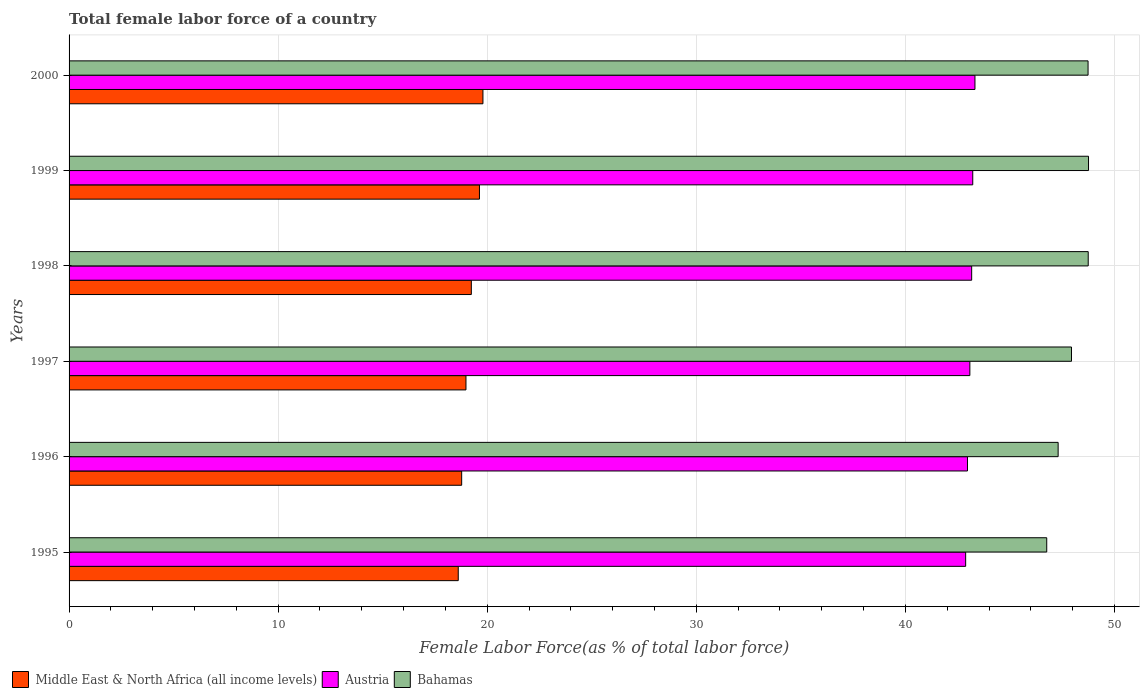How many different coloured bars are there?
Offer a very short reply. 3. Are the number of bars on each tick of the Y-axis equal?
Your answer should be very brief. Yes. In how many cases, is the number of bars for a given year not equal to the number of legend labels?
Provide a succinct answer. 0. What is the percentage of female labor force in Austria in 1999?
Offer a terse response. 43.22. Across all years, what is the maximum percentage of female labor force in Austria?
Your answer should be very brief. 43.33. Across all years, what is the minimum percentage of female labor force in Bahamas?
Your response must be concise. 46.76. What is the total percentage of female labor force in Bahamas in the graph?
Your answer should be compact. 288.25. What is the difference between the percentage of female labor force in Middle East & North Africa (all income levels) in 1995 and that in 1996?
Your answer should be compact. -0.16. What is the difference between the percentage of female labor force in Austria in 2000 and the percentage of female labor force in Bahamas in 1997?
Keep it short and to the point. -4.62. What is the average percentage of female labor force in Austria per year?
Give a very brief answer. 43.11. In the year 1995, what is the difference between the percentage of female labor force in Bahamas and percentage of female labor force in Middle East & North Africa (all income levels)?
Offer a very short reply. 28.15. In how many years, is the percentage of female labor force in Bahamas greater than 12 %?
Your answer should be compact. 6. What is the ratio of the percentage of female labor force in Middle East & North Africa (all income levels) in 1998 to that in 1999?
Your answer should be very brief. 0.98. What is the difference between the highest and the second highest percentage of female labor force in Bahamas?
Offer a very short reply. 0.01. What is the difference between the highest and the lowest percentage of female labor force in Austria?
Keep it short and to the point. 0.44. In how many years, is the percentage of female labor force in Bahamas greater than the average percentage of female labor force in Bahamas taken over all years?
Keep it short and to the point. 3. Is the sum of the percentage of female labor force in Austria in 1997 and 1998 greater than the maximum percentage of female labor force in Middle East & North Africa (all income levels) across all years?
Your answer should be very brief. Yes. What does the 1st bar from the top in 1999 represents?
Give a very brief answer. Bahamas. What does the 1st bar from the bottom in 1995 represents?
Your answer should be very brief. Middle East & North Africa (all income levels). Is it the case that in every year, the sum of the percentage of female labor force in Austria and percentage of female labor force in Middle East & North Africa (all income levels) is greater than the percentage of female labor force in Bahamas?
Keep it short and to the point. Yes. How many bars are there?
Give a very brief answer. 18. How many years are there in the graph?
Offer a terse response. 6. What is the difference between two consecutive major ticks on the X-axis?
Provide a short and direct response. 10. Does the graph contain any zero values?
Give a very brief answer. No. Does the graph contain grids?
Give a very brief answer. Yes. Where does the legend appear in the graph?
Make the answer very short. Bottom left. How many legend labels are there?
Your answer should be compact. 3. How are the legend labels stacked?
Offer a terse response. Horizontal. What is the title of the graph?
Your response must be concise. Total female labor force of a country. What is the label or title of the X-axis?
Offer a very short reply. Female Labor Force(as % of total labor force). What is the label or title of the Y-axis?
Keep it short and to the point. Years. What is the Female Labor Force(as % of total labor force) in Middle East & North Africa (all income levels) in 1995?
Ensure brevity in your answer.  18.61. What is the Female Labor Force(as % of total labor force) of Austria in 1995?
Ensure brevity in your answer.  42.88. What is the Female Labor Force(as % of total labor force) in Bahamas in 1995?
Offer a terse response. 46.76. What is the Female Labor Force(as % of total labor force) in Middle East & North Africa (all income levels) in 1996?
Your answer should be compact. 18.78. What is the Female Labor Force(as % of total labor force) of Austria in 1996?
Ensure brevity in your answer.  42.97. What is the Female Labor Force(as % of total labor force) in Bahamas in 1996?
Provide a succinct answer. 47.3. What is the Female Labor Force(as % of total labor force) in Middle East & North Africa (all income levels) in 1997?
Keep it short and to the point. 18.98. What is the Female Labor Force(as % of total labor force) in Austria in 1997?
Provide a short and direct response. 43.08. What is the Female Labor Force(as % of total labor force) of Bahamas in 1997?
Offer a very short reply. 47.94. What is the Female Labor Force(as % of total labor force) in Middle East & North Africa (all income levels) in 1998?
Give a very brief answer. 19.24. What is the Female Labor Force(as % of total labor force) in Austria in 1998?
Provide a succinct answer. 43.17. What is the Female Labor Force(as % of total labor force) in Bahamas in 1998?
Keep it short and to the point. 48.74. What is the Female Labor Force(as % of total labor force) of Middle East & North Africa (all income levels) in 1999?
Make the answer very short. 19.63. What is the Female Labor Force(as % of total labor force) in Austria in 1999?
Provide a succinct answer. 43.22. What is the Female Labor Force(as % of total labor force) in Bahamas in 1999?
Keep it short and to the point. 48.76. What is the Female Labor Force(as % of total labor force) in Middle East & North Africa (all income levels) in 2000?
Your answer should be very brief. 19.79. What is the Female Labor Force(as % of total labor force) in Austria in 2000?
Make the answer very short. 43.33. What is the Female Labor Force(as % of total labor force) in Bahamas in 2000?
Give a very brief answer. 48.74. Across all years, what is the maximum Female Labor Force(as % of total labor force) of Middle East & North Africa (all income levels)?
Give a very brief answer. 19.79. Across all years, what is the maximum Female Labor Force(as % of total labor force) of Austria?
Offer a terse response. 43.33. Across all years, what is the maximum Female Labor Force(as % of total labor force) in Bahamas?
Give a very brief answer. 48.76. Across all years, what is the minimum Female Labor Force(as % of total labor force) of Middle East & North Africa (all income levels)?
Your answer should be very brief. 18.61. Across all years, what is the minimum Female Labor Force(as % of total labor force) in Austria?
Give a very brief answer. 42.88. Across all years, what is the minimum Female Labor Force(as % of total labor force) in Bahamas?
Your response must be concise. 46.76. What is the total Female Labor Force(as % of total labor force) of Middle East & North Africa (all income levels) in the graph?
Offer a very short reply. 115.03. What is the total Female Labor Force(as % of total labor force) of Austria in the graph?
Make the answer very short. 258.65. What is the total Female Labor Force(as % of total labor force) of Bahamas in the graph?
Offer a terse response. 288.25. What is the difference between the Female Labor Force(as % of total labor force) of Middle East & North Africa (all income levels) in 1995 and that in 1996?
Offer a terse response. -0.16. What is the difference between the Female Labor Force(as % of total labor force) in Austria in 1995 and that in 1996?
Offer a terse response. -0.09. What is the difference between the Female Labor Force(as % of total labor force) in Bahamas in 1995 and that in 1996?
Make the answer very short. -0.55. What is the difference between the Female Labor Force(as % of total labor force) of Middle East & North Africa (all income levels) in 1995 and that in 1997?
Ensure brevity in your answer.  -0.37. What is the difference between the Female Labor Force(as % of total labor force) in Austria in 1995 and that in 1997?
Your answer should be very brief. -0.2. What is the difference between the Female Labor Force(as % of total labor force) of Bahamas in 1995 and that in 1997?
Provide a succinct answer. -1.18. What is the difference between the Female Labor Force(as % of total labor force) of Middle East & North Africa (all income levels) in 1995 and that in 1998?
Keep it short and to the point. -0.63. What is the difference between the Female Labor Force(as % of total labor force) of Austria in 1995 and that in 1998?
Your answer should be very brief. -0.29. What is the difference between the Female Labor Force(as % of total labor force) of Bahamas in 1995 and that in 1998?
Your response must be concise. -1.98. What is the difference between the Female Labor Force(as % of total labor force) in Middle East & North Africa (all income levels) in 1995 and that in 1999?
Offer a very short reply. -1.01. What is the difference between the Female Labor Force(as % of total labor force) in Austria in 1995 and that in 1999?
Your response must be concise. -0.34. What is the difference between the Female Labor Force(as % of total labor force) of Bahamas in 1995 and that in 1999?
Your response must be concise. -2. What is the difference between the Female Labor Force(as % of total labor force) in Middle East & North Africa (all income levels) in 1995 and that in 2000?
Ensure brevity in your answer.  -1.18. What is the difference between the Female Labor Force(as % of total labor force) of Austria in 1995 and that in 2000?
Offer a very short reply. -0.44. What is the difference between the Female Labor Force(as % of total labor force) of Bahamas in 1995 and that in 2000?
Your answer should be compact. -1.98. What is the difference between the Female Labor Force(as % of total labor force) in Middle East & North Africa (all income levels) in 1996 and that in 1997?
Your response must be concise. -0.21. What is the difference between the Female Labor Force(as % of total labor force) of Austria in 1996 and that in 1997?
Your answer should be very brief. -0.11. What is the difference between the Female Labor Force(as % of total labor force) of Bahamas in 1996 and that in 1997?
Your answer should be very brief. -0.64. What is the difference between the Female Labor Force(as % of total labor force) of Middle East & North Africa (all income levels) in 1996 and that in 1998?
Keep it short and to the point. -0.46. What is the difference between the Female Labor Force(as % of total labor force) in Austria in 1996 and that in 1998?
Your answer should be very brief. -0.2. What is the difference between the Female Labor Force(as % of total labor force) of Bahamas in 1996 and that in 1998?
Give a very brief answer. -1.44. What is the difference between the Female Labor Force(as % of total labor force) in Middle East & North Africa (all income levels) in 1996 and that in 1999?
Give a very brief answer. -0.85. What is the difference between the Female Labor Force(as % of total labor force) in Austria in 1996 and that in 1999?
Your answer should be compact. -0.25. What is the difference between the Female Labor Force(as % of total labor force) in Bahamas in 1996 and that in 1999?
Your response must be concise. -1.45. What is the difference between the Female Labor Force(as % of total labor force) of Middle East & North Africa (all income levels) in 1996 and that in 2000?
Ensure brevity in your answer.  -1.02. What is the difference between the Female Labor Force(as % of total labor force) in Austria in 1996 and that in 2000?
Provide a short and direct response. -0.36. What is the difference between the Female Labor Force(as % of total labor force) in Bahamas in 1996 and that in 2000?
Make the answer very short. -1.43. What is the difference between the Female Labor Force(as % of total labor force) in Middle East & North Africa (all income levels) in 1997 and that in 1998?
Your answer should be very brief. -0.26. What is the difference between the Female Labor Force(as % of total labor force) in Austria in 1997 and that in 1998?
Your response must be concise. -0.09. What is the difference between the Female Labor Force(as % of total labor force) of Bahamas in 1997 and that in 1998?
Your answer should be very brief. -0.8. What is the difference between the Female Labor Force(as % of total labor force) of Middle East & North Africa (all income levels) in 1997 and that in 1999?
Ensure brevity in your answer.  -0.65. What is the difference between the Female Labor Force(as % of total labor force) in Austria in 1997 and that in 1999?
Provide a succinct answer. -0.14. What is the difference between the Female Labor Force(as % of total labor force) of Bahamas in 1997 and that in 1999?
Make the answer very short. -0.81. What is the difference between the Female Labor Force(as % of total labor force) of Middle East & North Africa (all income levels) in 1997 and that in 2000?
Give a very brief answer. -0.81. What is the difference between the Female Labor Force(as % of total labor force) of Austria in 1997 and that in 2000?
Your response must be concise. -0.24. What is the difference between the Female Labor Force(as % of total labor force) of Bahamas in 1997 and that in 2000?
Provide a short and direct response. -0.79. What is the difference between the Female Labor Force(as % of total labor force) in Middle East & North Africa (all income levels) in 1998 and that in 1999?
Keep it short and to the point. -0.39. What is the difference between the Female Labor Force(as % of total labor force) in Austria in 1998 and that in 1999?
Your response must be concise. -0.05. What is the difference between the Female Labor Force(as % of total labor force) in Bahamas in 1998 and that in 1999?
Ensure brevity in your answer.  -0.01. What is the difference between the Female Labor Force(as % of total labor force) in Middle East & North Africa (all income levels) in 1998 and that in 2000?
Provide a short and direct response. -0.55. What is the difference between the Female Labor Force(as % of total labor force) of Austria in 1998 and that in 2000?
Your answer should be very brief. -0.16. What is the difference between the Female Labor Force(as % of total labor force) of Bahamas in 1998 and that in 2000?
Give a very brief answer. 0.01. What is the difference between the Female Labor Force(as % of total labor force) of Middle East & North Africa (all income levels) in 1999 and that in 2000?
Offer a very short reply. -0.17. What is the difference between the Female Labor Force(as % of total labor force) of Austria in 1999 and that in 2000?
Your answer should be compact. -0.11. What is the difference between the Female Labor Force(as % of total labor force) of Bahamas in 1999 and that in 2000?
Your answer should be very brief. 0.02. What is the difference between the Female Labor Force(as % of total labor force) in Middle East & North Africa (all income levels) in 1995 and the Female Labor Force(as % of total labor force) in Austria in 1996?
Ensure brevity in your answer.  -24.36. What is the difference between the Female Labor Force(as % of total labor force) of Middle East & North Africa (all income levels) in 1995 and the Female Labor Force(as % of total labor force) of Bahamas in 1996?
Your response must be concise. -28.69. What is the difference between the Female Labor Force(as % of total labor force) in Austria in 1995 and the Female Labor Force(as % of total labor force) in Bahamas in 1996?
Your answer should be very brief. -4.42. What is the difference between the Female Labor Force(as % of total labor force) of Middle East & North Africa (all income levels) in 1995 and the Female Labor Force(as % of total labor force) of Austria in 1997?
Offer a very short reply. -24.47. What is the difference between the Female Labor Force(as % of total labor force) in Middle East & North Africa (all income levels) in 1995 and the Female Labor Force(as % of total labor force) in Bahamas in 1997?
Provide a short and direct response. -29.33. What is the difference between the Female Labor Force(as % of total labor force) in Austria in 1995 and the Female Labor Force(as % of total labor force) in Bahamas in 1997?
Give a very brief answer. -5.06. What is the difference between the Female Labor Force(as % of total labor force) in Middle East & North Africa (all income levels) in 1995 and the Female Labor Force(as % of total labor force) in Austria in 1998?
Offer a terse response. -24.56. What is the difference between the Female Labor Force(as % of total labor force) of Middle East & North Africa (all income levels) in 1995 and the Female Labor Force(as % of total labor force) of Bahamas in 1998?
Give a very brief answer. -30.13. What is the difference between the Female Labor Force(as % of total labor force) in Austria in 1995 and the Female Labor Force(as % of total labor force) in Bahamas in 1998?
Provide a short and direct response. -5.86. What is the difference between the Female Labor Force(as % of total labor force) in Middle East & North Africa (all income levels) in 1995 and the Female Labor Force(as % of total labor force) in Austria in 1999?
Provide a short and direct response. -24.61. What is the difference between the Female Labor Force(as % of total labor force) of Middle East & North Africa (all income levels) in 1995 and the Female Labor Force(as % of total labor force) of Bahamas in 1999?
Ensure brevity in your answer.  -30.14. What is the difference between the Female Labor Force(as % of total labor force) in Austria in 1995 and the Female Labor Force(as % of total labor force) in Bahamas in 1999?
Ensure brevity in your answer.  -5.88. What is the difference between the Female Labor Force(as % of total labor force) of Middle East & North Africa (all income levels) in 1995 and the Female Labor Force(as % of total labor force) of Austria in 2000?
Give a very brief answer. -24.71. What is the difference between the Female Labor Force(as % of total labor force) in Middle East & North Africa (all income levels) in 1995 and the Female Labor Force(as % of total labor force) in Bahamas in 2000?
Ensure brevity in your answer.  -30.12. What is the difference between the Female Labor Force(as % of total labor force) in Austria in 1995 and the Female Labor Force(as % of total labor force) in Bahamas in 2000?
Make the answer very short. -5.85. What is the difference between the Female Labor Force(as % of total labor force) of Middle East & North Africa (all income levels) in 1996 and the Female Labor Force(as % of total labor force) of Austria in 1997?
Offer a very short reply. -24.3. What is the difference between the Female Labor Force(as % of total labor force) in Middle East & North Africa (all income levels) in 1996 and the Female Labor Force(as % of total labor force) in Bahamas in 1997?
Provide a short and direct response. -29.17. What is the difference between the Female Labor Force(as % of total labor force) in Austria in 1996 and the Female Labor Force(as % of total labor force) in Bahamas in 1997?
Your answer should be compact. -4.97. What is the difference between the Female Labor Force(as % of total labor force) of Middle East & North Africa (all income levels) in 1996 and the Female Labor Force(as % of total labor force) of Austria in 1998?
Offer a very short reply. -24.39. What is the difference between the Female Labor Force(as % of total labor force) in Middle East & North Africa (all income levels) in 1996 and the Female Labor Force(as % of total labor force) in Bahamas in 1998?
Offer a very short reply. -29.97. What is the difference between the Female Labor Force(as % of total labor force) in Austria in 1996 and the Female Labor Force(as % of total labor force) in Bahamas in 1998?
Keep it short and to the point. -5.77. What is the difference between the Female Labor Force(as % of total labor force) in Middle East & North Africa (all income levels) in 1996 and the Female Labor Force(as % of total labor force) in Austria in 1999?
Offer a terse response. -24.44. What is the difference between the Female Labor Force(as % of total labor force) in Middle East & North Africa (all income levels) in 1996 and the Female Labor Force(as % of total labor force) in Bahamas in 1999?
Offer a terse response. -29.98. What is the difference between the Female Labor Force(as % of total labor force) of Austria in 1996 and the Female Labor Force(as % of total labor force) of Bahamas in 1999?
Provide a short and direct response. -5.79. What is the difference between the Female Labor Force(as % of total labor force) in Middle East & North Africa (all income levels) in 1996 and the Female Labor Force(as % of total labor force) in Austria in 2000?
Your answer should be compact. -24.55. What is the difference between the Female Labor Force(as % of total labor force) in Middle East & North Africa (all income levels) in 1996 and the Female Labor Force(as % of total labor force) in Bahamas in 2000?
Your answer should be compact. -29.96. What is the difference between the Female Labor Force(as % of total labor force) of Austria in 1996 and the Female Labor Force(as % of total labor force) of Bahamas in 2000?
Offer a very short reply. -5.77. What is the difference between the Female Labor Force(as % of total labor force) of Middle East & North Africa (all income levels) in 1997 and the Female Labor Force(as % of total labor force) of Austria in 1998?
Ensure brevity in your answer.  -24.19. What is the difference between the Female Labor Force(as % of total labor force) in Middle East & North Africa (all income levels) in 1997 and the Female Labor Force(as % of total labor force) in Bahamas in 1998?
Provide a succinct answer. -29.76. What is the difference between the Female Labor Force(as % of total labor force) in Austria in 1997 and the Female Labor Force(as % of total labor force) in Bahamas in 1998?
Provide a succinct answer. -5.66. What is the difference between the Female Labor Force(as % of total labor force) in Middle East & North Africa (all income levels) in 1997 and the Female Labor Force(as % of total labor force) in Austria in 1999?
Provide a succinct answer. -24.24. What is the difference between the Female Labor Force(as % of total labor force) of Middle East & North Africa (all income levels) in 1997 and the Female Labor Force(as % of total labor force) of Bahamas in 1999?
Offer a terse response. -29.78. What is the difference between the Female Labor Force(as % of total labor force) of Austria in 1997 and the Female Labor Force(as % of total labor force) of Bahamas in 1999?
Provide a succinct answer. -5.68. What is the difference between the Female Labor Force(as % of total labor force) in Middle East & North Africa (all income levels) in 1997 and the Female Labor Force(as % of total labor force) in Austria in 2000?
Ensure brevity in your answer.  -24.34. What is the difference between the Female Labor Force(as % of total labor force) in Middle East & North Africa (all income levels) in 1997 and the Female Labor Force(as % of total labor force) in Bahamas in 2000?
Offer a very short reply. -29.75. What is the difference between the Female Labor Force(as % of total labor force) in Austria in 1997 and the Female Labor Force(as % of total labor force) in Bahamas in 2000?
Give a very brief answer. -5.65. What is the difference between the Female Labor Force(as % of total labor force) of Middle East & North Africa (all income levels) in 1998 and the Female Labor Force(as % of total labor force) of Austria in 1999?
Your answer should be very brief. -23.98. What is the difference between the Female Labor Force(as % of total labor force) in Middle East & North Africa (all income levels) in 1998 and the Female Labor Force(as % of total labor force) in Bahamas in 1999?
Provide a short and direct response. -29.52. What is the difference between the Female Labor Force(as % of total labor force) of Austria in 1998 and the Female Labor Force(as % of total labor force) of Bahamas in 1999?
Make the answer very short. -5.59. What is the difference between the Female Labor Force(as % of total labor force) of Middle East & North Africa (all income levels) in 1998 and the Female Labor Force(as % of total labor force) of Austria in 2000?
Provide a succinct answer. -24.09. What is the difference between the Female Labor Force(as % of total labor force) in Middle East & North Africa (all income levels) in 1998 and the Female Labor Force(as % of total labor force) in Bahamas in 2000?
Provide a short and direct response. -29.5. What is the difference between the Female Labor Force(as % of total labor force) of Austria in 1998 and the Female Labor Force(as % of total labor force) of Bahamas in 2000?
Your answer should be very brief. -5.57. What is the difference between the Female Labor Force(as % of total labor force) in Middle East & North Africa (all income levels) in 1999 and the Female Labor Force(as % of total labor force) in Austria in 2000?
Ensure brevity in your answer.  -23.7. What is the difference between the Female Labor Force(as % of total labor force) of Middle East & North Africa (all income levels) in 1999 and the Female Labor Force(as % of total labor force) of Bahamas in 2000?
Your answer should be compact. -29.11. What is the difference between the Female Labor Force(as % of total labor force) of Austria in 1999 and the Female Labor Force(as % of total labor force) of Bahamas in 2000?
Give a very brief answer. -5.51. What is the average Female Labor Force(as % of total labor force) in Middle East & North Africa (all income levels) per year?
Keep it short and to the point. 19.17. What is the average Female Labor Force(as % of total labor force) of Austria per year?
Offer a very short reply. 43.11. What is the average Female Labor Force(as % of total labor force) in Bahamas per year?
Your answer should be compact. 48.04. In the year 1995, what is the difference between the Female Labor Force(as % of total labor force) of Middle East & North Africa (all income levels) and Female Labor Force(as % of total labor force) of Austria?
Give a very brief answer. -24.27. In the year 1995, what is the difference between the Female Labor Force(as % of total labor force) in Middle East & North Africa (all income levels) and Female Labor Force(as % of total labor force) in Bahamas?
Keep it short and to the point. -28.15. In the year 1995, what is the difference between the Female Labor Force(as % of total labor force) of Austria and Female Labor Force(as % of total labor force) of Bahamas?
Provide a short and direct response. -3.88. In the year 1996, what is the difference between the Female Labor Force(as % of total labor force) of Middle East & North Africa (all income levels) and Female Labor Force(as % of total labor force) of Austria?
Offer a very short reply. -24.19. In the year 1996, what is the difference between the Female Labor Force(as % of total labor force) of Middle East & North Africa (all income levels) and Female Labor Force(as % of total labor force) of Bahamas?
Ensure brevity in your answer.  -28.53. In the year 1996, what is the difference between the Female Labor Force(as % of total labor force) in Austria and Female Labor Force(as % of total labor force) in Bahamas?
Provide a succinct answer. -4.34. In the year 1997, what is the difference between the Female Labor Force(as % of total labor force) in Middle East & North Africa (all income levels) and Female Labor Force(as % of total labor force) in Austria?
Make the answer very short. -24.1. In the year 1997, what is the difference between the Female Labor Force(as % of total labor force) of Middle East & North Africa (all income levels) and Female Labor Force(as % of total labor force) of Bahamas?
Offer a terse response. -28.96. In the year 1997, what is the difference between the Female Labor Force(as % of total labor force) of Austria and Female Labor Force(as % of total labor force) of Bahamas?
Your answer should be very brief. -4.86. In the year 1998, what is the difference between the Female Labor Force(as % of total labor force) in Middle East & North Africa (all income levels) and Female Labor Force(as % of total labor force) in Austria?
Your answer should be very brief. -23.93. In the year 1998, what is the difference between the Female Labor Force(as % of total labor force) in Middle East & North Africa (all income levels) and Female Labor Force(as % of total labor force) in Bahamas?
Ensure brevity in your answer.  -29.5. In the year 1998, what is the difference between the Female Labor Force(as % of total labor force) in Austria and Female Labor Force(as % of total labor force) in Bahamas?
Your answer should be very brief. -5.57. In the year 1999, what is the difference between the Female Labor Force(as % of total labor force) of Middle East & North Africa (all income levels) and Female Labor Force(as % of total labor force) of Austria?
Your response must be concise. -23.59. In the year 1999, what is the difference between the Female Labor Force(as % of total labor force) of Middle East & North Africa (all income levels) and Female Labor Force(as % of total labor force) of Bahamas?
Provide a succinct answer. -29.13. In the year 1999, what is the difference between the Female Labor Force(as % of total labor force) of Austria and Female Labor Force(as % of total labor force) of Bahamas?
Your answer should be very brief. -5.54. In the year 2000, what is the difference between the Female Labor Force(as % of total labor force) of Middle East & North Africa (all income levels) and Female Labor Force(as % of total labor force) of Austria?
Ensure brevity in your answer.  -23.53. In the year 2000, what is the difference between the Female Labor Force(as % of total labor force) in Middle East & North Africa (all income levels) and Female Labor Force(as % of total labor force) in Bahamas?
Make the answer very short. -28.94. In the year 2000, what is the difference between the Female Labor Force(as % of total labor force) of Austria and Female Labor Force(as % of total labor force) of Bahamas?
Your answer should be compact. -5.41. What is the ratio of the Female Labor Force(as % of total labor force) of Middle East & North Africa (all income levels) in 1995 to that in 1997?
Your response must be concise. 0.98. What is the ratio of the Female Labor Force(as % of total labor force) in Austria in 1995 to that in 1997?
Provide a short and direct response. 1. What is the ratio of the Female Labor Force(as % of total labor force) in Bahamas in 1995 to that in 1997?
Offer a very short reply. 0.98. What is the ratio of the Female Labor Force(as % of total labor force) in Middle East & North Africa (all income levels) in 1995 to that in 1998?
Your answer should be very brief. 0.97. What is the ratio of the Female Labor Force(as % of total labor force) in Bahamas in 1995 to that in 1998?
Your response must be concise. 0.96. What is the ratio of the Female Labor Force(as % of total labor force) of Middle East & North Africa (all income levels) in 1995 to that in 1999?
Provide a short and direct response. 0.95. What is the ratio of the Female Labor Force(as % of total labor force) in Austria in 1995 to that in 1999?
Keep it short and to the point. 0.99. What is the ratio of the Female Labor Force(as % of total labor force) in Middle East & North Africa (all income levels) in 1995 to that in 2000?
Offer a very short reply. 0.94. What is the ratio of the Female Labor Force(as % of total labor force) in Austria in 1995 to that in 2000?
Your response must be concise. 0.99. What is the ratio of the Female Labor Force(as % of total labor force) of Bahamas in 1995 to that in 2000?
Your response must be concise. 0.96. What is the ratio of the Female Labor Force(as % of total labor force) of Austria in 1996 to that in 1997?
Ensure brevity in your answer.  1. What is the ratio of the Female Labor Force(as % of total labor force) of Bahamas in 1996 to that in 1997?
Your answer should be very brief. 0.99. What is the ratio of the Female Labor Force(as % of total labor force) of Middle East & North Africa (all income levels) in 1996 to that in 1998?
Provide a short and direct response. 0.98. What is the ratio of the Female Labor Force(as % of total labor force) in Bahamas in 1996 to that in 1998?
Your response must be concise. 0.97. What is the ratio of the Female Labor Force(as % of total labor force) in Middle East & North Africa (all income levels) in 1996 to that in 1999?
Offer a terse response. 0.96. What is the ratio of the Female Labor Force(as % of total labor force) in Bahamas in 1996 to that in 1999?
Provide a short and direct response. 0.97. What is the ratio of the Female Labor Force(as % of total labor force) of Middle East & North Africa (all income levels) in 1996 to that in 2000?
Keep it short and to the point. 0.95. What is the ratio of the Female Labor Force(as % of total labor force) in Bahamas in 1996 to that in 2000?
Your answer should be very brief. 0.97. What is the ratio of the Female Labor Force(as % of total labor force) of Middle East & North Africa (all income levels) in 1997 to that in 1998?
Your response must be concise. 0.99. What is the ratio of the Female Labor Force(as % of total labor force) of Bahamas in 1997 to that in 1998?
Your answer should be very brief. 0.98. What is the ratio of the Female Labor Force(as % of total labor force) in Middle East & North Africa (all income levels) in 1997 to that in 1999?
Provide a succinct answer. 0.97. What is the ratio of the Female Labor Force(as % of total labor force) in Bahamas in 1997 to that in 1999?
Provide a short and direct response. 0.98. What is the ratio of the Female Labor Force(as % of total labor force) of Austria in 1997 to that in 2000?
Give a very brief answer. 0.99. What is the ratio of the Female Labor Force(as % of total labor force) in Bahamas in 1997 to that in 2000?
Your answer should be very brief. 0.98. What is the ratio of the Female Labor Force(as % of total labor force) of Middle East & North Africa (all income levels) in 1998 to that in 1999?
Keep it short and to the point. 0.98. What is the ratio of the Female Labor Force(as % of total labor force) in Middle East & North Africa (all income levels) in 1998 to that in 2000?
Give a very brief answer. 0.97. What is the ratio of the Female Labor Force(as % of total labor force) of Austria in 1998 to that in 2000?
Make the answer very short. 1. What is the difference between the highest and the second highest Female Labor Force(as % of total labor force) of Middle East & North Africa (all income levels)?
Your answer should be very brief. 0.17. What is the difference between the highest and the second highest Female Labor Force(as % of total labor force) in Austria?
Make the answer very short. 0.11. What is the difference between the highest and the second highest Female Labor Force(as % of total labor force) in Bahamas?
Ensure brevity in your answer.  0.01. What is the difference between the highest and the lowest Female Labor Force(as % of total labor force) of Middle East & North Africa (all income levels)?
Give a very brief answer. 1.18. What is the difference between the highest and the lowest Female Labor Force(as % of total labor force) of Austria?
Your response must be concise. 0.44. What is the difference between the highest and the lowest Female Labor Force(as % of total labor force) in Bahamas?
Give a very brief answer. 2. 